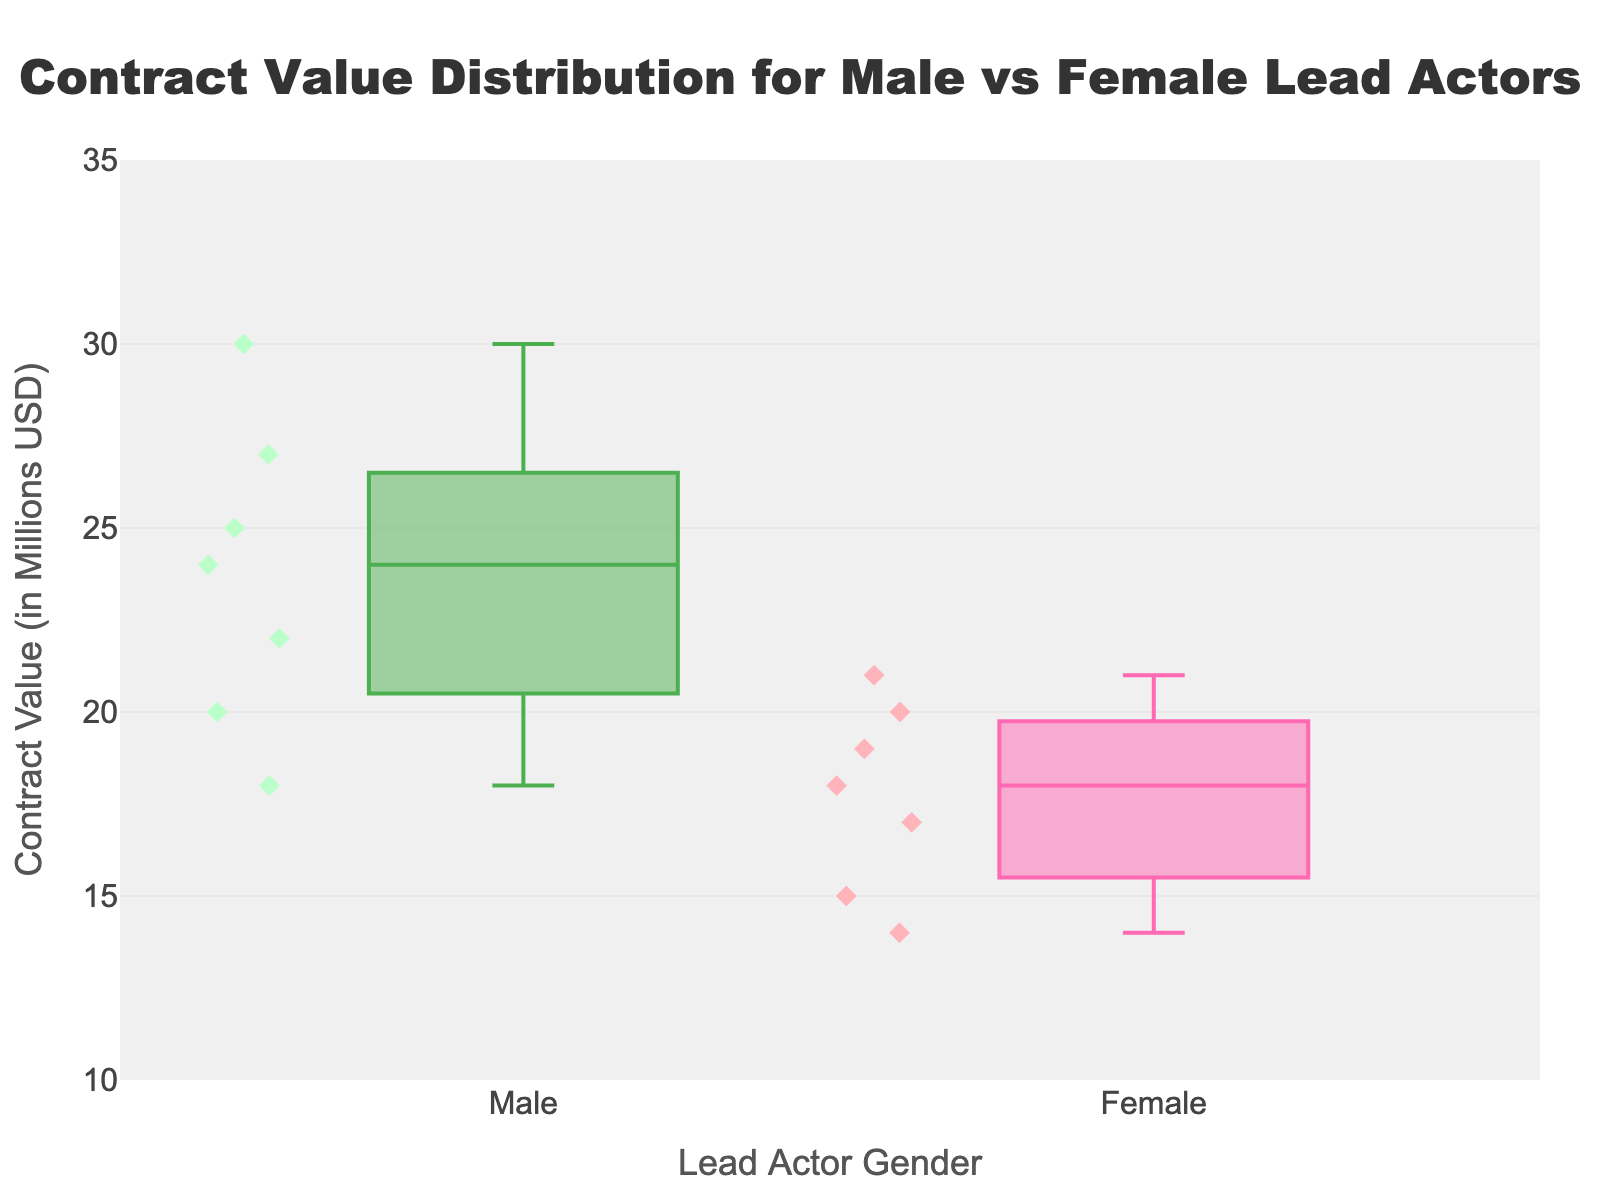What is the title of the plot? The title is at the top center of the plot, written in a large, bold font. It reads "Contract Value Distribution for Male vs Female Lead Actors."
Answer: Contract Value Distribution for Male vs Female Lead Actors What are the two groups displayed on the x-axis? The x-axis shows the categories for the "Lead Actor Gender." There are two groups displayed: "Male" and "Female."
Answer: Male and Female Which gender group has a higher median contract value? In a box plot, the median value is represented by the line inside the box. You need to identify which box has the higher median line.
Answer: Male What is the range of contract values for male lead actors? The range in a box plot is shown by the whiskers. For male lead actors, the minimum value is 18 and the maximum is 30.
Answer: 18 to 30 million USD What is the median contract value for female lead actors? Locate the line inside the box for female lead actors. The median value line is at 18 million USD.
Answer: 18 million USD Which gender group has more variability in contract values? Variability in a box plot can be assessed by looking at the interquartile range (IQR), which is the length of the box.
Answer: Male What is the maximum contract value for female lead actors? The maximum value in a box plot is shown by the top whisker. For female lead actors, this is at 21 million USD.
Answer: 21 million USD How many data points are plotted for each gender? In each box plot, we see individual data points represented by diamonds. There are 7 points for both male and female.
Answer: 7 for each Are there any outliers present in the plot? Outliers in a box plot are typically shown as points beyond the whiskers. This plot does not show any points beyond the whiskers.
Answer: No What is the interquartile range (IQR) for male lead actors? The IQR is the range between the first quartile (Q1) and the third quartile (Q3), which is the length of the box. The box ranges from 21 to 27 million USD. So, the IQR is 27 - 21 = 6.
Answer: 6 million USD 